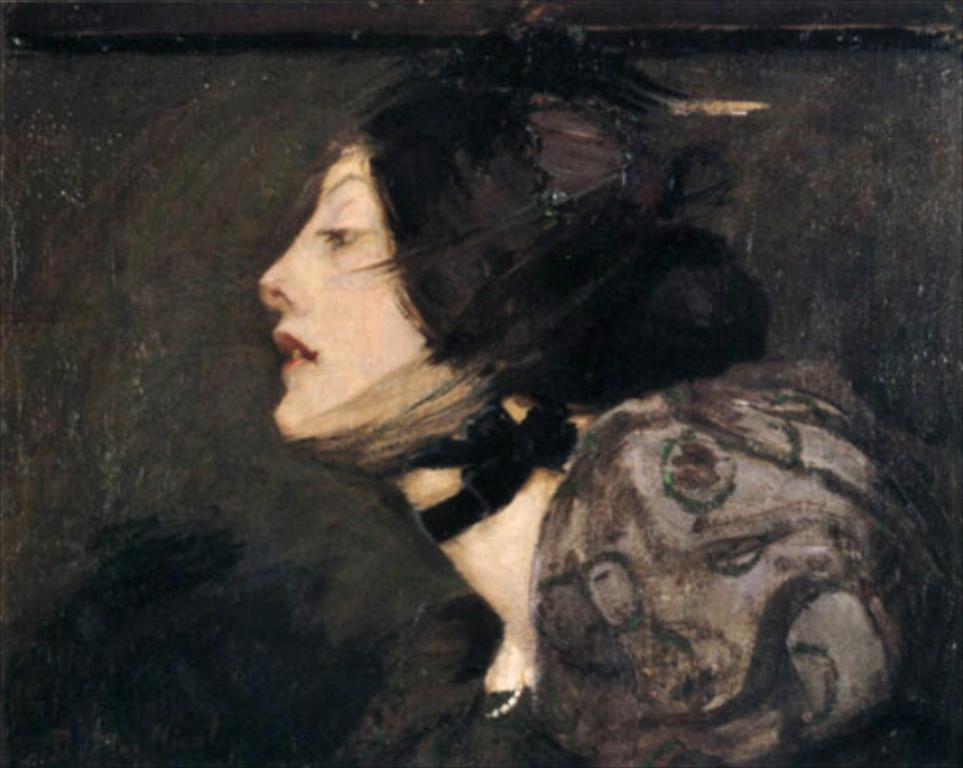In one or two sentences, can you explain what this image depicts? This is the picture of the painting. In this picture, we see a woman is wearing the black dress. In the background, it is black in color. 